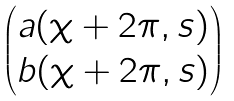<formula> <loc_0><loc_0><loc_500><loc_500>\begin{pmatrix} a ( \chi + 2 \pi , s ) \\ b ( \chi + 2 \pi , s ) \end{pmatrix}</formula> 